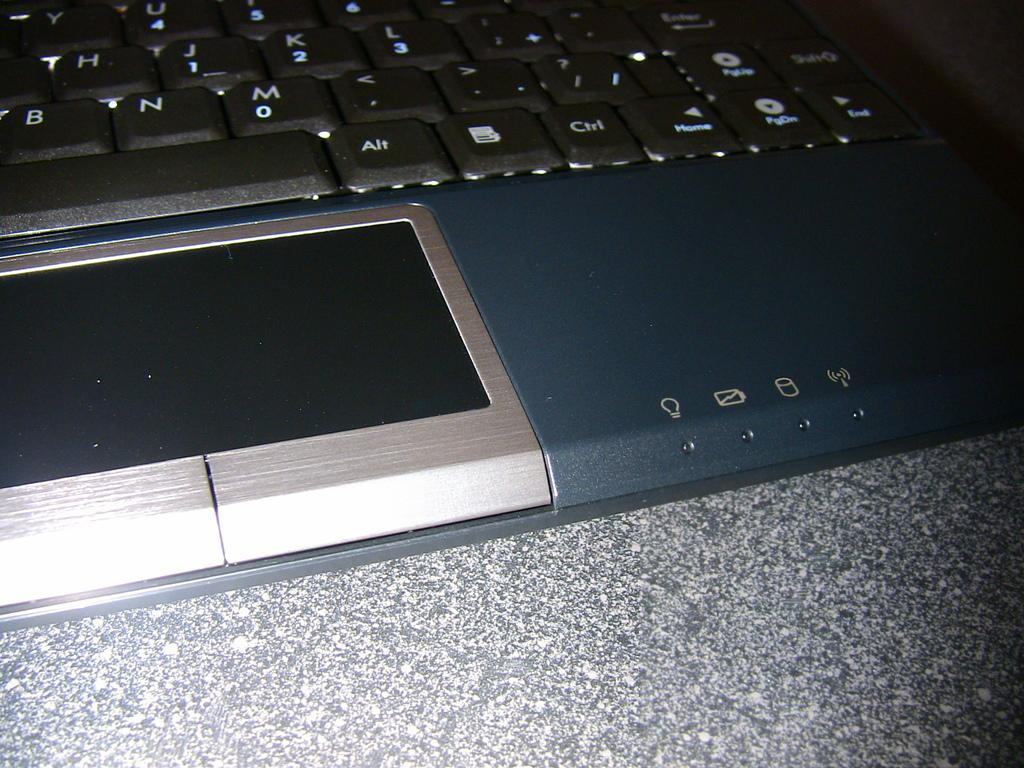<image>
Give a short and clear explanation of the subsequent image. A laptop is shown with the Alt and Ctrl keys displayed at the bottom 